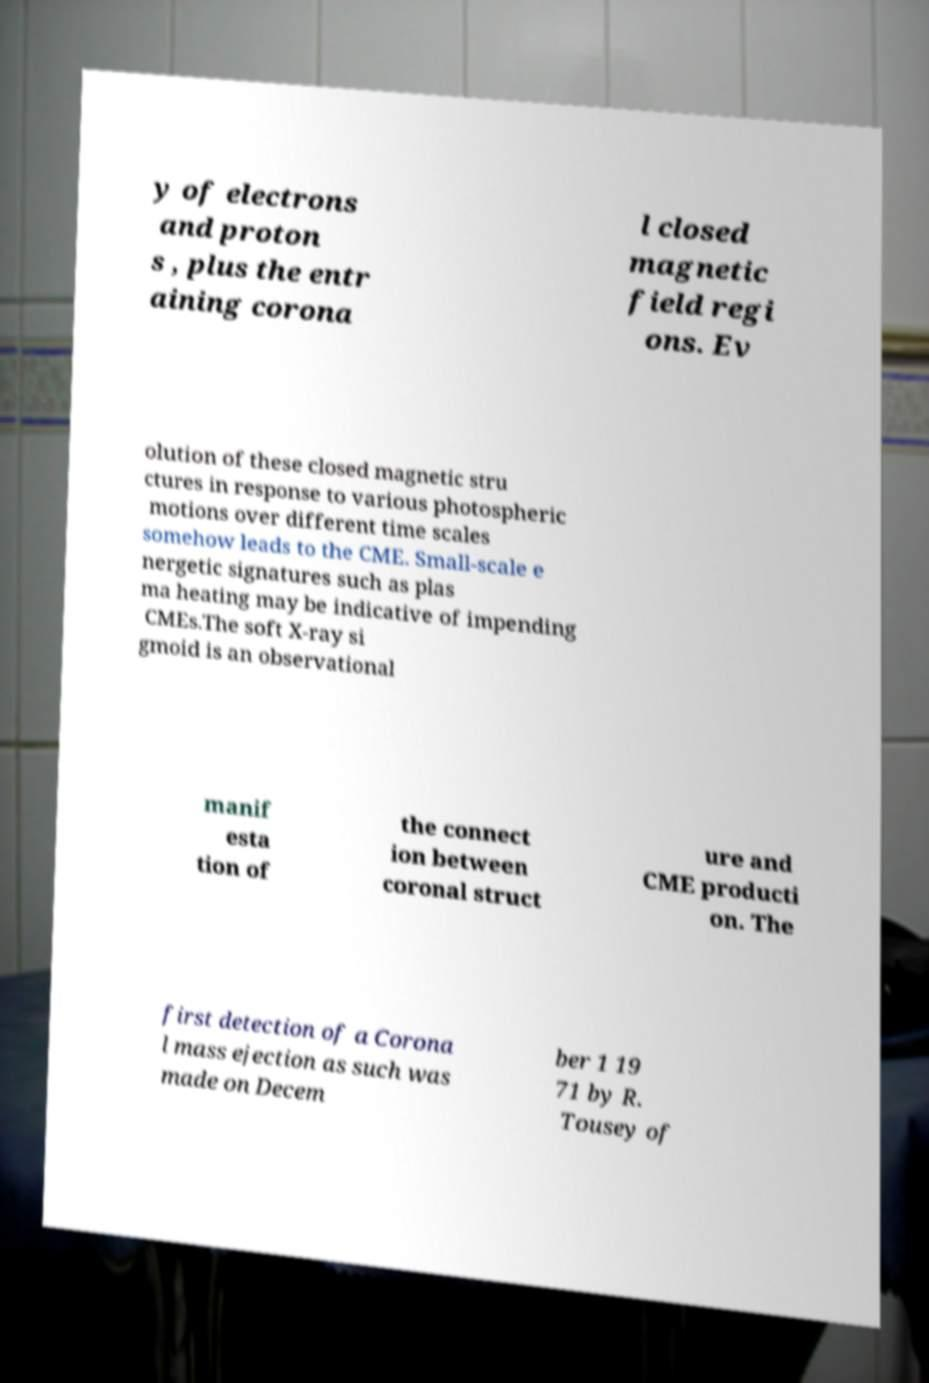I need the written content from this picture converted into text. Can you do that? y of electrons and proton s , plus the entr aining corona l closed magnetic field regi ons. Ev olution of these closed magnetic stru ctures in response to various photospheric motions over different time scales somehow leads to the CME. Small-scale e nergetic signatures such as plas ma heating may be indicative of impending CMEs.The soft X-ray si gmoid is an observational manif esta tion of the connect ion between coronal struct ure and CME producti on. The first detection of a Corona l mass ejection as such was made on Decem ber 1 19 71 by R. Tousey of 